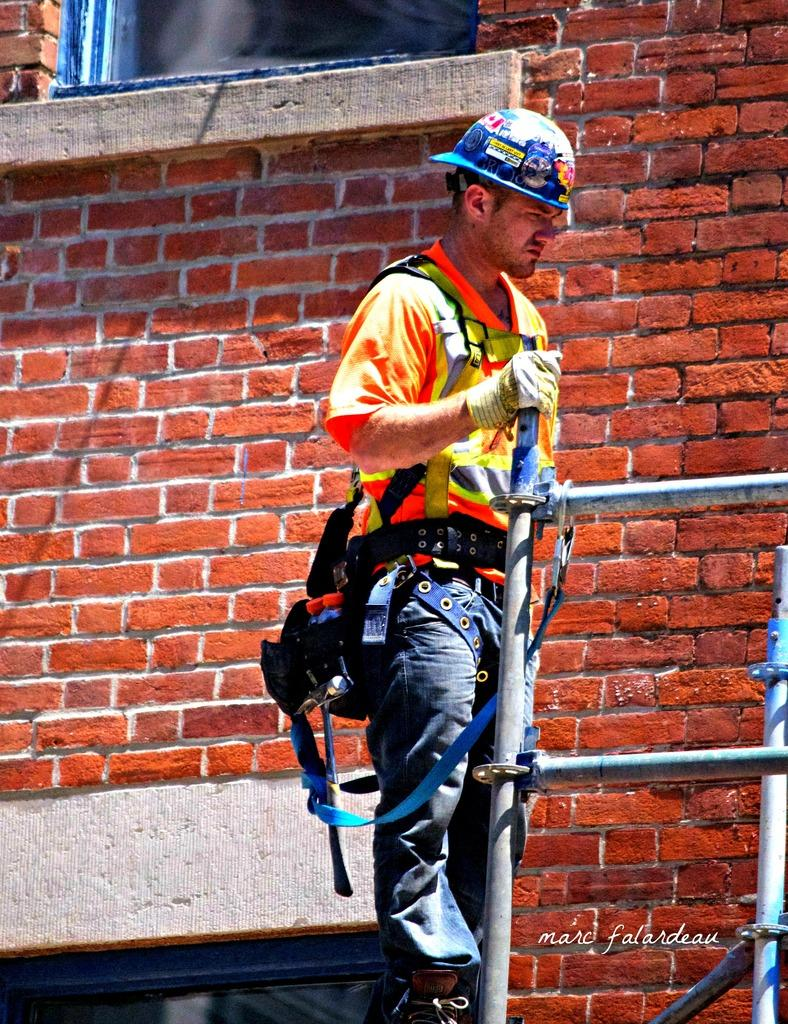What is the main subject of the image? The main subject of the image is a man. What is the man doing in the image? The man is standing in the image. What is the man wearing on his head? The man is wearing a helmet. What color is the man's t-shirt? The man is wearing an orange t-shirt. What type of pants is the man wearing? The man is wearing jeans. What can be seen in the background of the image? There is a building in the background of the image. What feature of the building is visible? There is a window on the top of the building. What type of railings are present in the image? There are metal railings in the image. What historical event is the man participating in, as depicted in the image? There is no indication of a historical event in the image; it simply shows a man standing while wearing a helmet, an orange t-shirt, and jeans, with a building and metal railings in the background. 